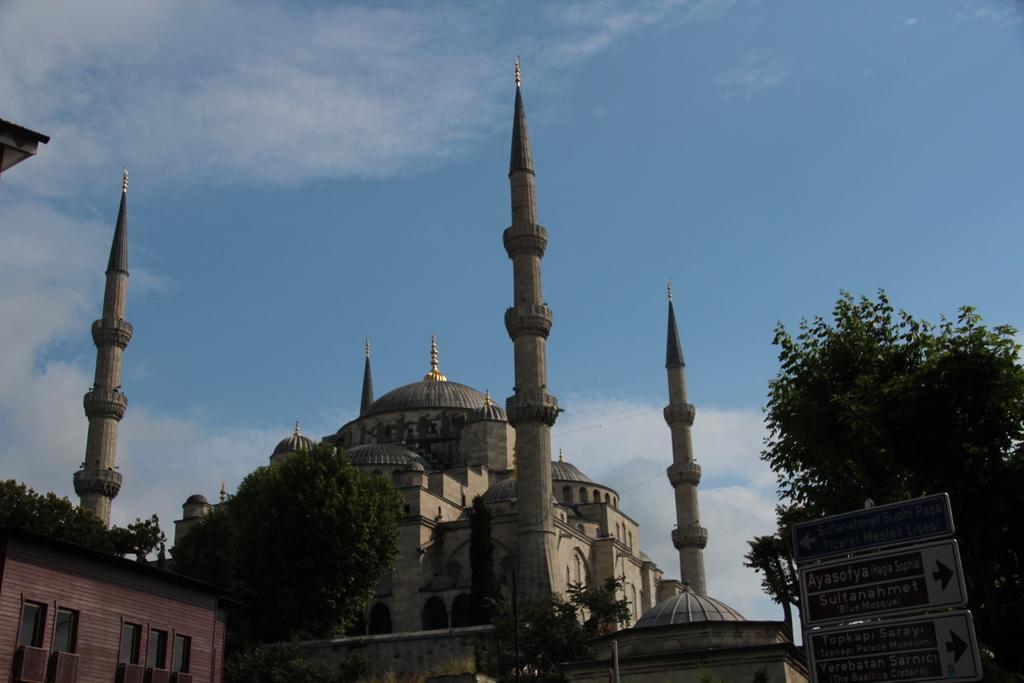Can you describe this image briefly? In this image, we can see a fort, few trees, house. Right side bottom, we can see sign boards. Background there is a sky. 